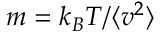Convert formula to latex. <formula><loc_0><loc_0><loc_500><loc_500>m = k _ { B } T / \langle v ^ { 2 } \rangle</formula> 